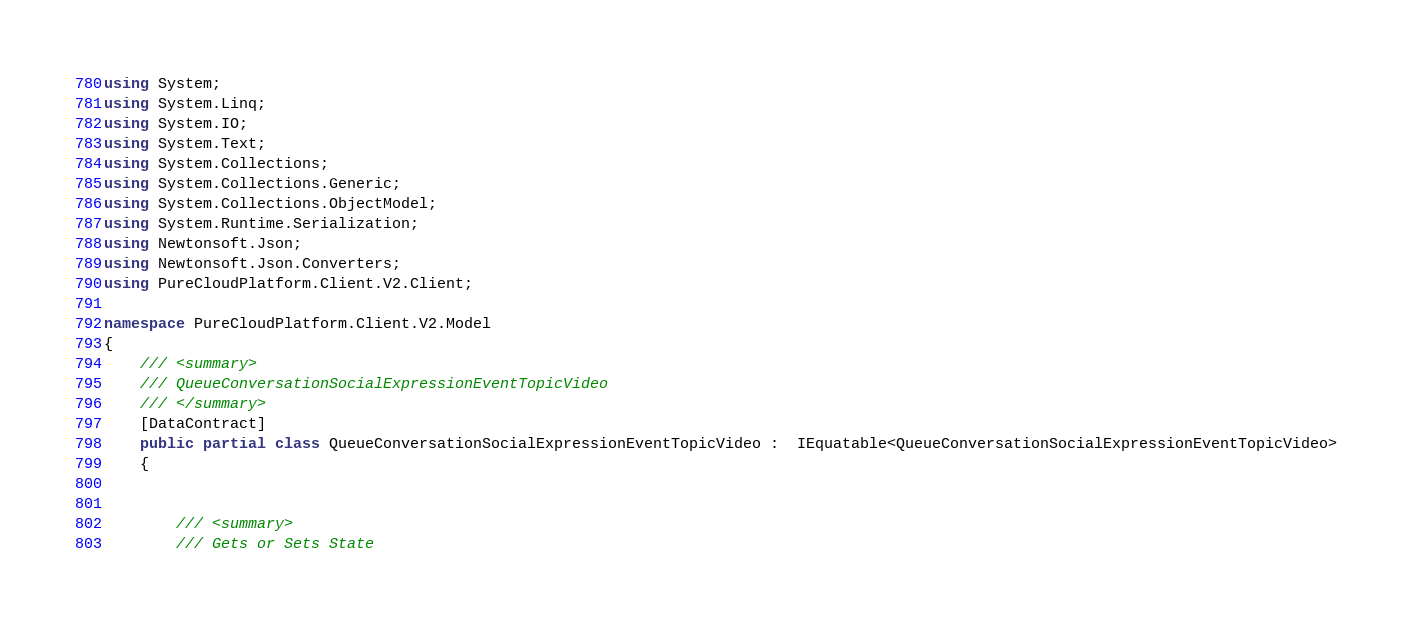<code> <loc_0><loc_0><loc_500><loc_500><_C#_>using System;
using System.Linq;
using System.IO;
using System.Text;
using System.Collections;
using System.Collections.Generic;
using System.Collections.ObjectModel;
using System.Runtime.Serialization;
using Newtonsoft.Json;
using Newtonsoft.Json.Converters;
using PureCloudPlatform.Client.V2.Client;

namespace PureCloudPlatform.Client.V2.Model
{
    /// <summary>
    /// QueueConversationSocialExpressionEventTopicVideo
    /// </summary>
    [DataContract]
    public partial class QueueConversationSocialExpressionEventTopicVideo :  IEquatable<QueueConversationSocialExpressionEventTopicVideo>
    {
        
        
        /// <summary>
        /// Gets or Sets State</code> 